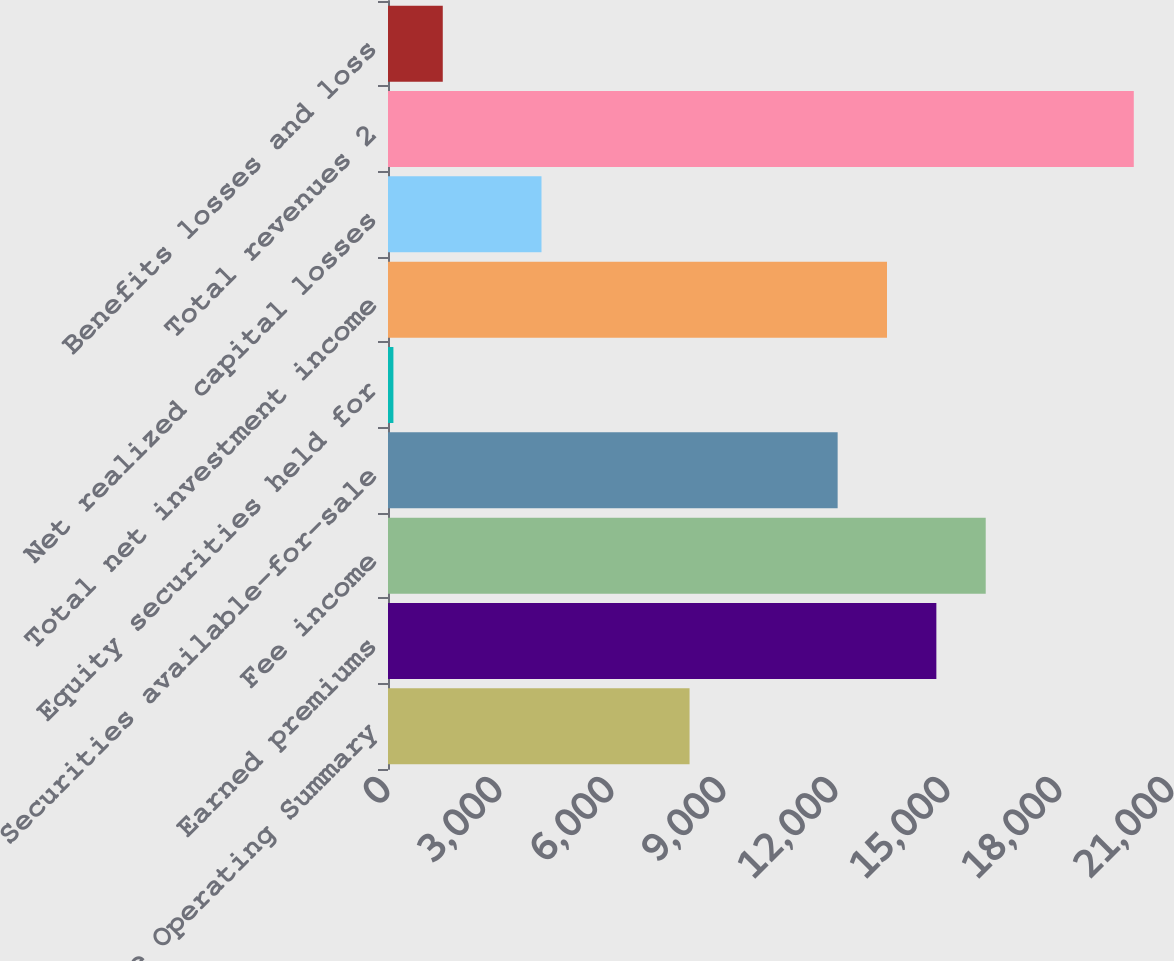Convert chart to OTSL. <chart><loc_0><loc_0><loc_500><loc_500><bar_chart><fcel>Life Operating Summary<fcel>Earned premiums<fcel>Fee income<fcel>Securities available-for-sale<fcel>Equity securities held for<fcel>Total net investment income<fcel>Net realized capital losses<fcel>Total revenues 2<fcel>Benefits losses and loss<nl><fcel>8077.6<fcel>14688.1<fcel>16010.2<fcel>12043.9<fcel>145<fcel>13366<fcel>4111.3<fcel>19976.5<fcel>1467.1<nl></chart> 